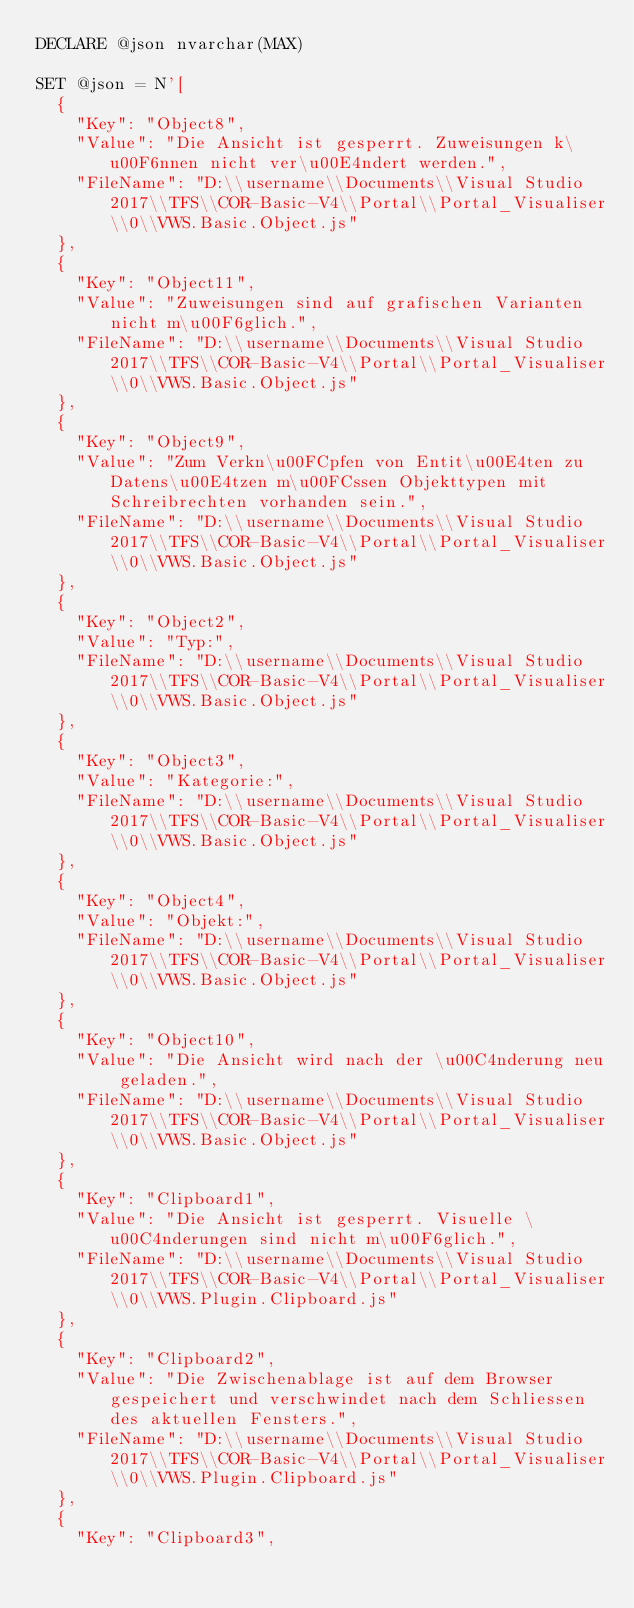Convert code to text. <code><loc_0><loc_0><loc_500><loc_500><_SQL_>DECLARE @json nvarchar(MAX) 

SET @json = N'[
  {
    "Key": "Object8",
    "Value": "Die Ansicht ist gesperrt. Zuweisungen k\u00F6nnen nicht ver\u00E4ndert werden.",
    "FileName": "D:\\username\\Documents\\Visual Studio 2017\\TFS\\COR-Basic-V4\\Portal\\Portal_Visualiser\\0\\VWS.Basic.Object.js"
  },
  {
    "Key": "Object11",
    "Value": "Zuweisungen sind auf grafischen Varianten nicht m\u00F6glich.",
    "FileName": "D:\\username\\Documents\\Visual Studio 2017\\TFS\\COR-Basic-V4\\Portal\\Portal_Visualiser\\0\\VWS.Basic.Object.js"
  },
  {
    "Key": "Object9",
    "Value": "Zum Verkn\u00FCpfen von Entit\u00E4ten zu Datens\u00E4tzen m\u00FCssen Objekttypen mit Schreibrechten vorhanden sein.",
    "FileName": "D:\\username\\Documents\\Visual Studio 2017\\TFS\\COR-Basic-V4\\Portal\\Portal_Visualiser\\0\\VWS.Basic.Object.js"
  },
  {
    "Key": "Object2",
    "Value": "Typ:",
    "FileName": "D:\\username\\Documents\\Visual Studio 2017\\TFS\\COR-Basic-V4\\Portal\\Portal_Visualiser\\0\\VWS.Basic.Object.js"
  },
  {
    "Key": "Object3",
    "Value": "Kategorie:",
    "FileName": "D:\\username\\Documents\\Visual Studio 2017\\TFS\\COR-Basic-V4\\Portal\\Portal_Visualiser\\0\\VWS.Basic.Object.js"
  },
  {
    "Key": "Object4",
    "Value": "Objekt:",
    "FileName": "D:\\username\\Documents\\Visual Studio 2017\\TFS\\COR-Basic-V4\\Portal\\Portal_Visualiser\\0\\VWS.Basic.Object.js"
  },
  {
    "Key": "Object10",
    "Value": "Die Ansicht wird nach der \u00C4nderung neu geladen.",
    "FileName": "D:\\username\\Documents\\Visual Studio 2017\\TFS\\COR-Basic-V4\\Portal\\Portal_Visualiser\\0\\VWS.Basic.Object.js"
  },
  {
    "Key": "Clipboard1",
    "Value": "Die Ansicht ist gesperrt. Visuelle \u00C4nderungen sind nicht m\u00F6glich.",
    "FileName": "D:\\username\\Documents\\Visual Studio 2017\\TFS\\COR-Basic-V4\\Portal\\Portal_Visualiser\\0\\VWS.Plugin.Clipboard.js"
  },
  {
    "Key": "Clipboard2",
    "Value": "Die Zwischenablage ist auf dem Browser gespeichert und verschwindet nach dem Schliessen des aktuellen Fensters.",
    "FileName": "D:\\username\\Documents\\Visual Studio 2017\\TFS\\COR-Basic-V4\\Portal\\Portal_Visualiser\\0\\VWS.Plugin.Clipboard.js"
  },
  {
    "Key": "Clipboard3",</code> 